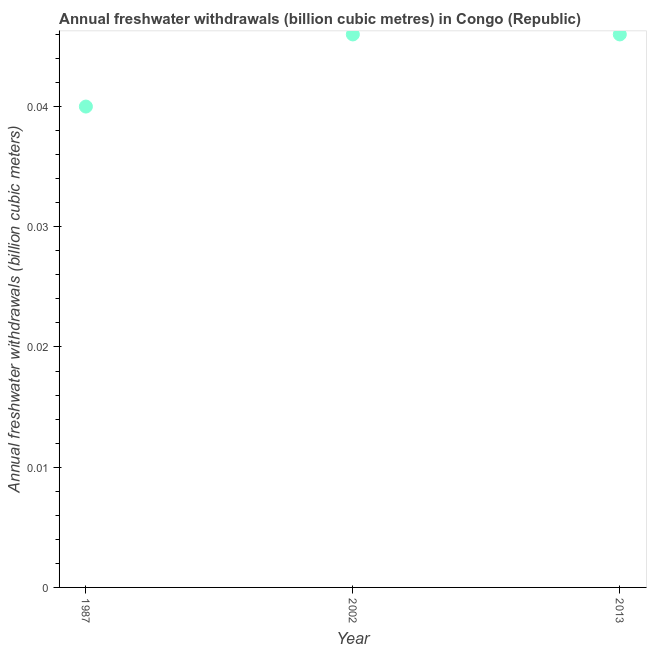What is the annual freshwater withdrawals in 2002?
Offer a terse response. 0.05. Across all years, what is the maximum annual freshwater withdrawals?
Offer a terse response. 0.05. Across all years, what is the minimum annual freshwater withdrawals?
Offer a very short reply. 0.04. What is the sum of the annual freshwater withdrawals?
Offer a terse response. 0.13. What is the difference between the annual freshwater withdrawals in 1987 and 2002?
Ensure brevity in your answer.  -0.01. What is the average annual freshwater withdrawals per year?
Provide a succinct answer. 0.04. What is the median annual freshwater withdrawals?
Keep it short and to the point. 0.05. In how many years, is the annual freshwater withdrawals greater than 0.022 billion cubic meters?
Give a very brief answer. 3. Do a majority of the years between 1987 and 2002 (inclusive) have annual freshwater withdrawals greater than 0.024 billion cubic meters?
Your answer should be compact. Yes. What is the ratio of the annual freshwater withdrawals in 2002 to that in 2013?
Offer a terse response. 1. Is the annual freshwater withdrawals in 2002 less than that in 2013?
Your response must be concise. No. Is the difference between the annual freshwater withdrawals in 1987 and 2002 greater than the difference between any two years?
Your answer should be compact. Yes. What is the difference between the highest and the lowest annual freshwater withdrawals?
Make the answer very short. 0.01. Does the annual freshwater withdrawals monotonically increase over the years?
Offer a terse response. No. How many dotlines are there?
Your response must be concise. 1. What is the difference between two consecutive major ticks on the Y-axis?
Offer a very short reply. 0.01. Are the values on the major ticks of Y-axis written in scientific E-notation?
Offer a very short reply. No. What is the title of the graph?
Ensure brevity in your answer.  Annual freshwater withdrawals (billion cubic metres) in Congo (Republic). What is the label or title of the X-axis?
Make the answer very short. Year. What is the label or title of the Y-axis?
Offer a very short reply. Annual freshwater withdrawals (billion cubic meters). What is the Annual freshwater withdrawals (billion cubic meters) in 2002?
Ensure brevity in your answer.  0.05. What is the Annual freshwater withdrawals (billion cubic meters) in 2013?
Your answer should be compact. 0.05. What is the difference between the Annual freshwater withdrawals (billion cubic meters) in 1987 and 2002?
Your answer should be compact. -0.01. What is the difference between the Annual freshwater withdrawals (billion cubic meters) in 1987 and 2013?
Your answer should be compact. -0.01. What is the difference between the Annual freshwater withdrawals (billion cubic meters) in 2002 and 2013?
Your answer should be very brief. 0. What is the ratio of the Annual freshwater withdrawals (billion cubic meters) in 1987 to that in 2002?
Provide a succinct answer. 0.87. What is the ratio of the Annual freshwater withdrawals (billion cubic meters) in 1987 to that in 2013?
Give a very brief answer. 0.87. 